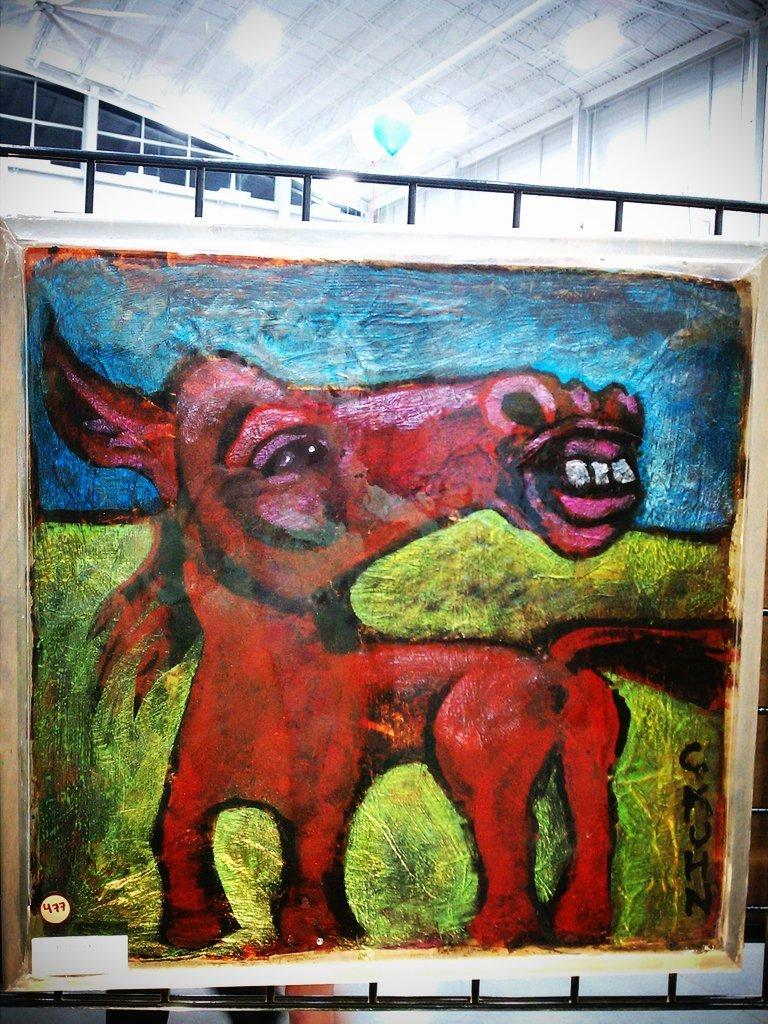What is depicted in the painting in the image? There is a painting of an animal in the image. What can be seen in the background of the image? There is a building in the background of the image. What is on top of the building in the image? There is a roof with lights on top of the building. What type of thread is being used by the writer in the image? There is no writer or thread present in the image. Who is the owner of the animal depicted in the painting in the image? The image does not provide information about the ownership of the animal depicted in the painting. 